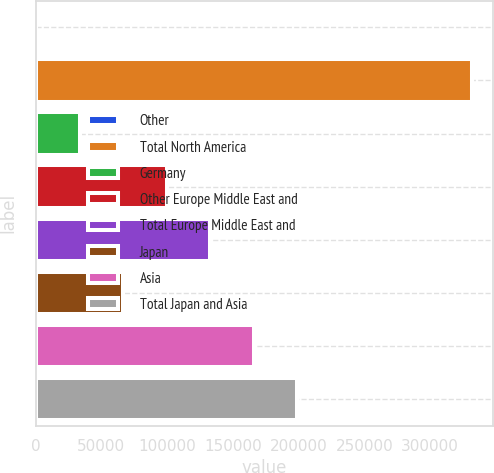<chart> <loc_0><loc_0><loc_500><loc_500><bar_chart><fcel>Other<fcel>Total North America<fcel>Germany<fcel>Other Europe Middle East and<fcel>Total Europe Middle East and<fcel>Japan<fcel>Asia<fcel>Total Japan and Asia<nl><fcel>227<fcel>331456<fcel>33349.9<fcel>99595.7<fcel>132719<fcel>66472.8<fcel>165842<fcel>198964<nl></chart> 